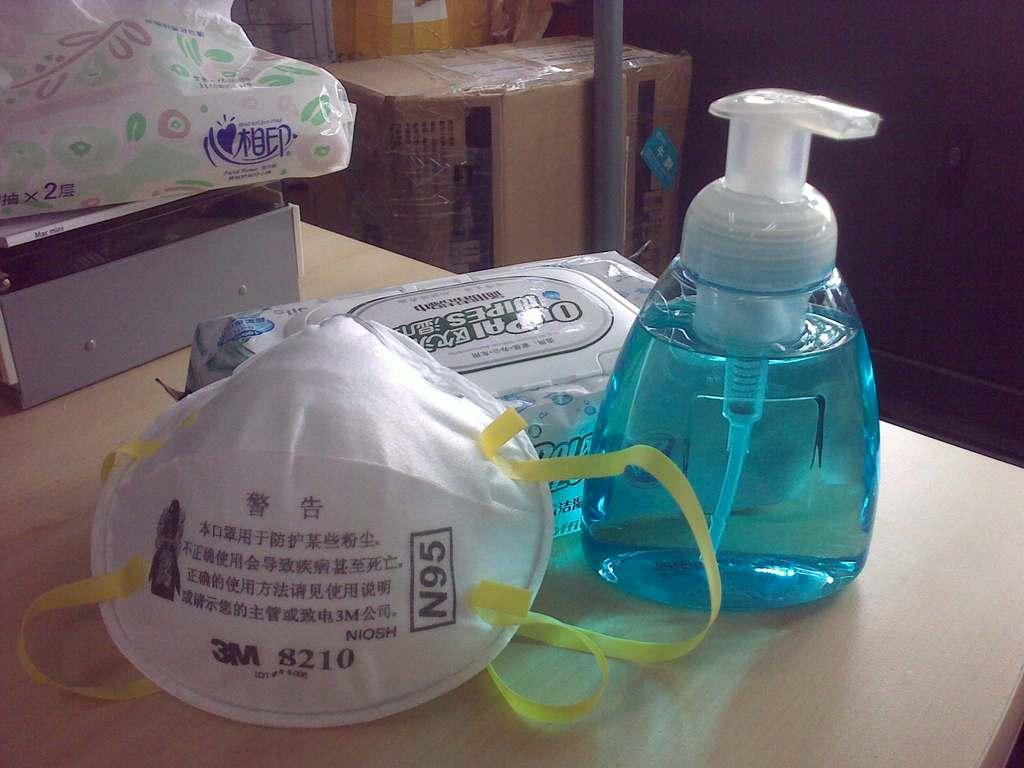What is one of the objects visible in the image? There is a bottle in the image. What type of surface can be seen beneath the objects in the image? There are objects on a wooden floor in the image. What can be seen at the top of the image? There are boxes at the top of the image. How many times do the people in the image kiss each other? There are no people visible in the image, so it is impossible to determine how many times they might kiss each other. 